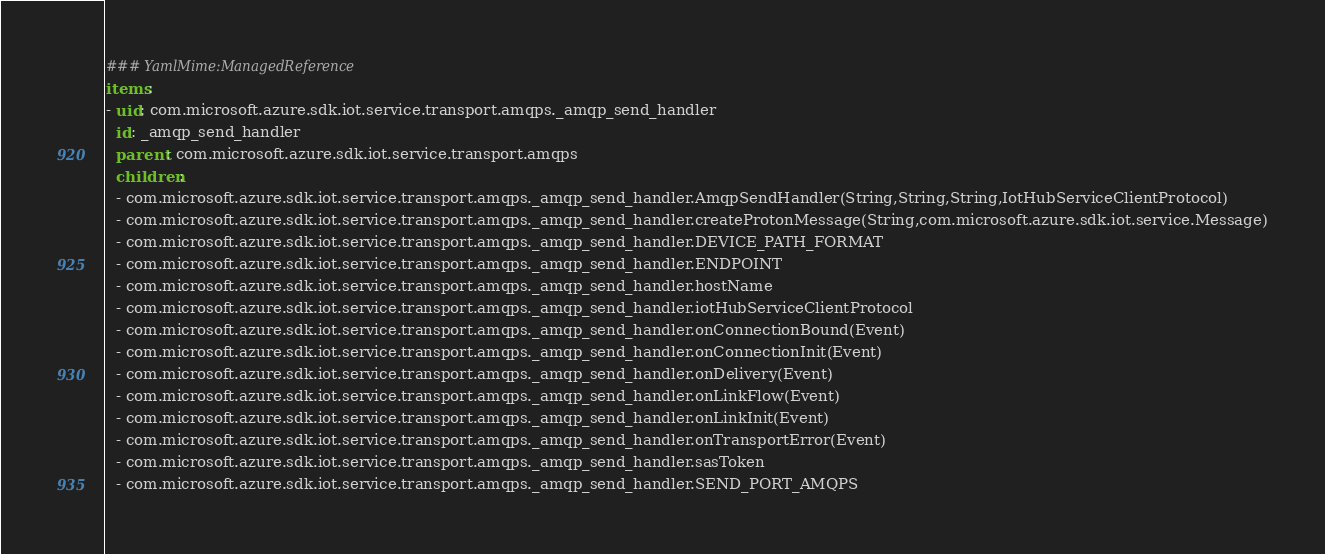Convert code to text. <code><loc_0><loc_0><loc_500><loc_500><_YAML_>### YamlMime:ManagedReference
items:
- uid: com.microsoft.azure.sdk.iot.service.transport.amqps._amqp_send_handler
  id: _amqp_send_handler
  parent: com.microsoft.azure.sdk.iot.service.transport.amqps
  children:
  - com.microsoft.azure.sdk.iot.service.transport.amqps._amqp_send_handler.AmqpSendHandler(String,String,String,IotHubServiceClientProtocol)
  - com.microsoft.azure.sdk.iot.service.transport.amqps._amqp_send_handler.createProtonMessage(String,com.microsoft.azure.sdk.iot.service.Message)
  - com.microsoft.azure.sdk.iot.service.transport.amqps._amqp_send_handler.DEVICE_PATH_FORMAT
  - com.microsoft.azure.sdk.iot.service.transport.amqps._amqp_send_handler.ENDPOINT
  - com.microsoft.azure.sdk.iot.service.transport.amqps._amqp_send_handler.hostName
  - com.microsoft.azure.sdk.iot.service.transport.amqps._amqp_send_handler.iotHubServiceClientProtocol
  - com.microsoft.azure.sdk.iot.service.transport.amqps._amqp_send_handler.onConnectionBound(Event)
  - com.microsoft.azure.sdk.iot.service.transport.amqps._amqp_send_handler.onConnectionInit(Event)
  - com.microsoft.azure.sdk.iot.service.transport.amqps._amqp_send_handler.onDelivery(Event)
  - com.microsoft.azure.sdk.iot.service.transport.amqps._amqp_send_handler.onLinkFlow(Event)
  - com.microsoft.azure.sdk.iot.service.transport.amqps._amqp_send_handler.onLinkInit(Event)
  - com.microsoft.azure.sdk.iot.service.transport.amqps._amqp_send_handler.onTransportError(Event)
  - com.microsoft.azure.sdk.iot.service.transport.amqps._amqp_send_handler.sasToken
  - com.microsoft.azure.sdk.iot.service.transport.amqps._amqp_send_handler.SEND_PORT_AMQPS</code> 